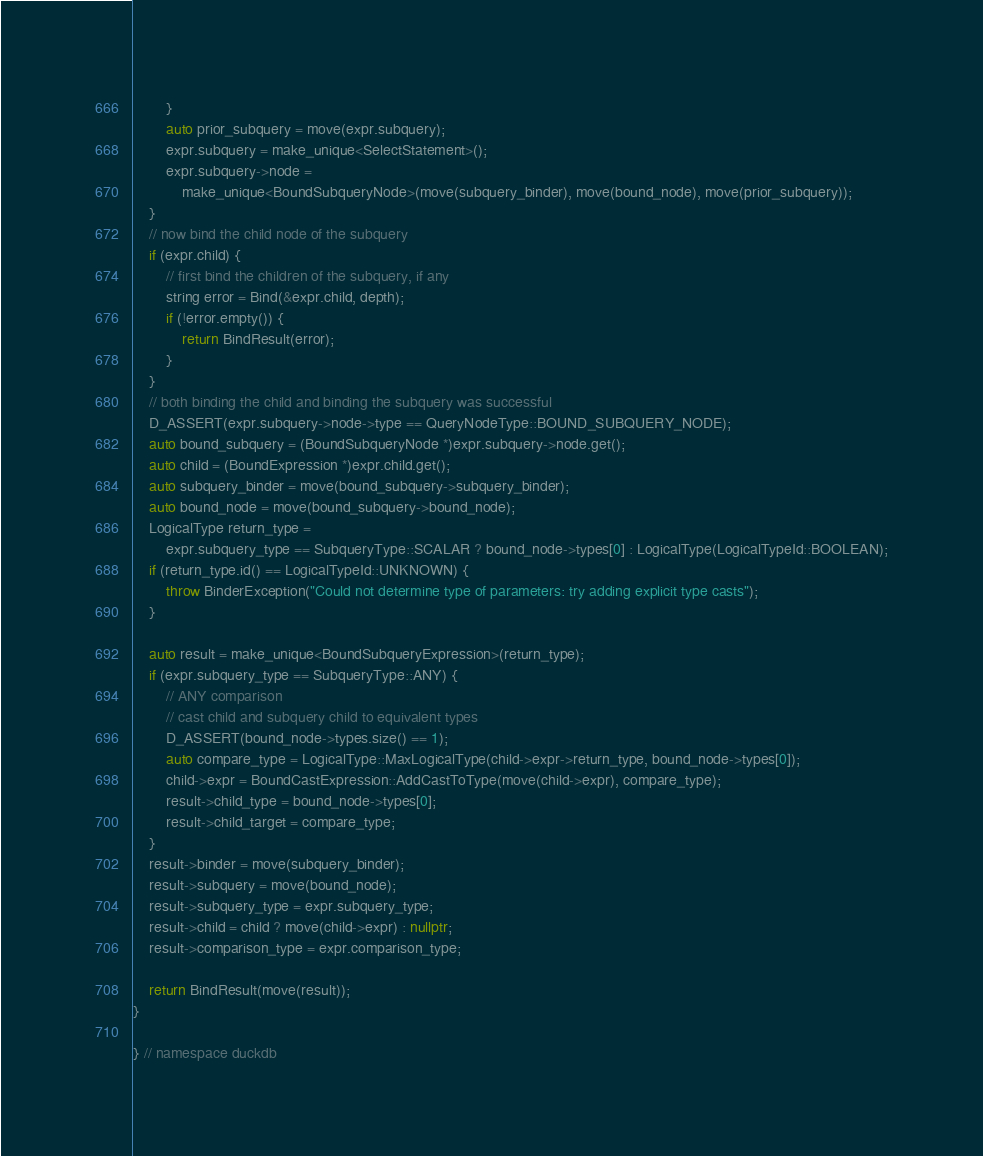Convert code to text. <code><loc_0><loc_0><loc_500><loc_500><_C++_>		}
		auto prior_subquery = move(expr.subquery);
		expr.subquery = make_unique<SelectStatement>();
		expr.subquery->node =
		    make_unique<BoundSubqueryNode>(move(subquery_binder), move(bound_node), move(prior_subquery));
	}
	// now bind the child node of the subquery
	if (expr.child) {
		// first bind the children of the subquery, if any
		string error = Bind(&expr.child, depth);
		if (!error.empty()) {
			return BindResult(error);
		}
	}
	// both binding the child and binding the subquery was successful
	D_ASSERT(expr.subquery->node->type == QueryNodeType::BOUND_SUBQUERY_NODE);
	auto bound_subquery = (BoundSubqueryNode *)expr.subquery->node.get();
	auto child = (BoundExpression *)expr.child.get();
	auto subquery_binder = move(bound_subquery->subquery_binder);
	auto bound_node = move(bound_subquery->bound_node);
	LogicalType return_type =
	    expr.subquery_type == SubqueryType::SCALAR ? bound_node->types[0] : LogicalType(LogicalTypeId::BOOLEAN);
	if (return_type.id() == LogicalTypeId::UNKNOWN) {
		throw BinderException("Could not determine type of parameters: try adding explicit type casts");
	}

	auto result = make_unique<BoundSubqueryExpression>(return_type);
	if (expr.subquery_type == SubqueryType::ANY) {
		// ANY comparison
		// cast child and subquery child to equivalent types
		D_ASSERT(bound_node->types.size() == 1);
		auto compare_type = LogicalType::MaxLogicalType(child->expr->return_type, bound_node->types[0]);
		child->expr = BoundCastExpression::AddCastToType(move(child->expr), compare_type);
		result->child_type = bound_node->types[0];
		result->child_target = compare_type;
	}
	result->binder = move(subquery_binder);
	result->subquery = move(bound_node);
	result->subquery_type = expr.subquery_type;
	result->child = child ? move(child->expr) : nullptr;
	result->comparison_type = expr.comparison_type;

	return BindResult(move(result));
}

} // namespace duckdb
</code> 